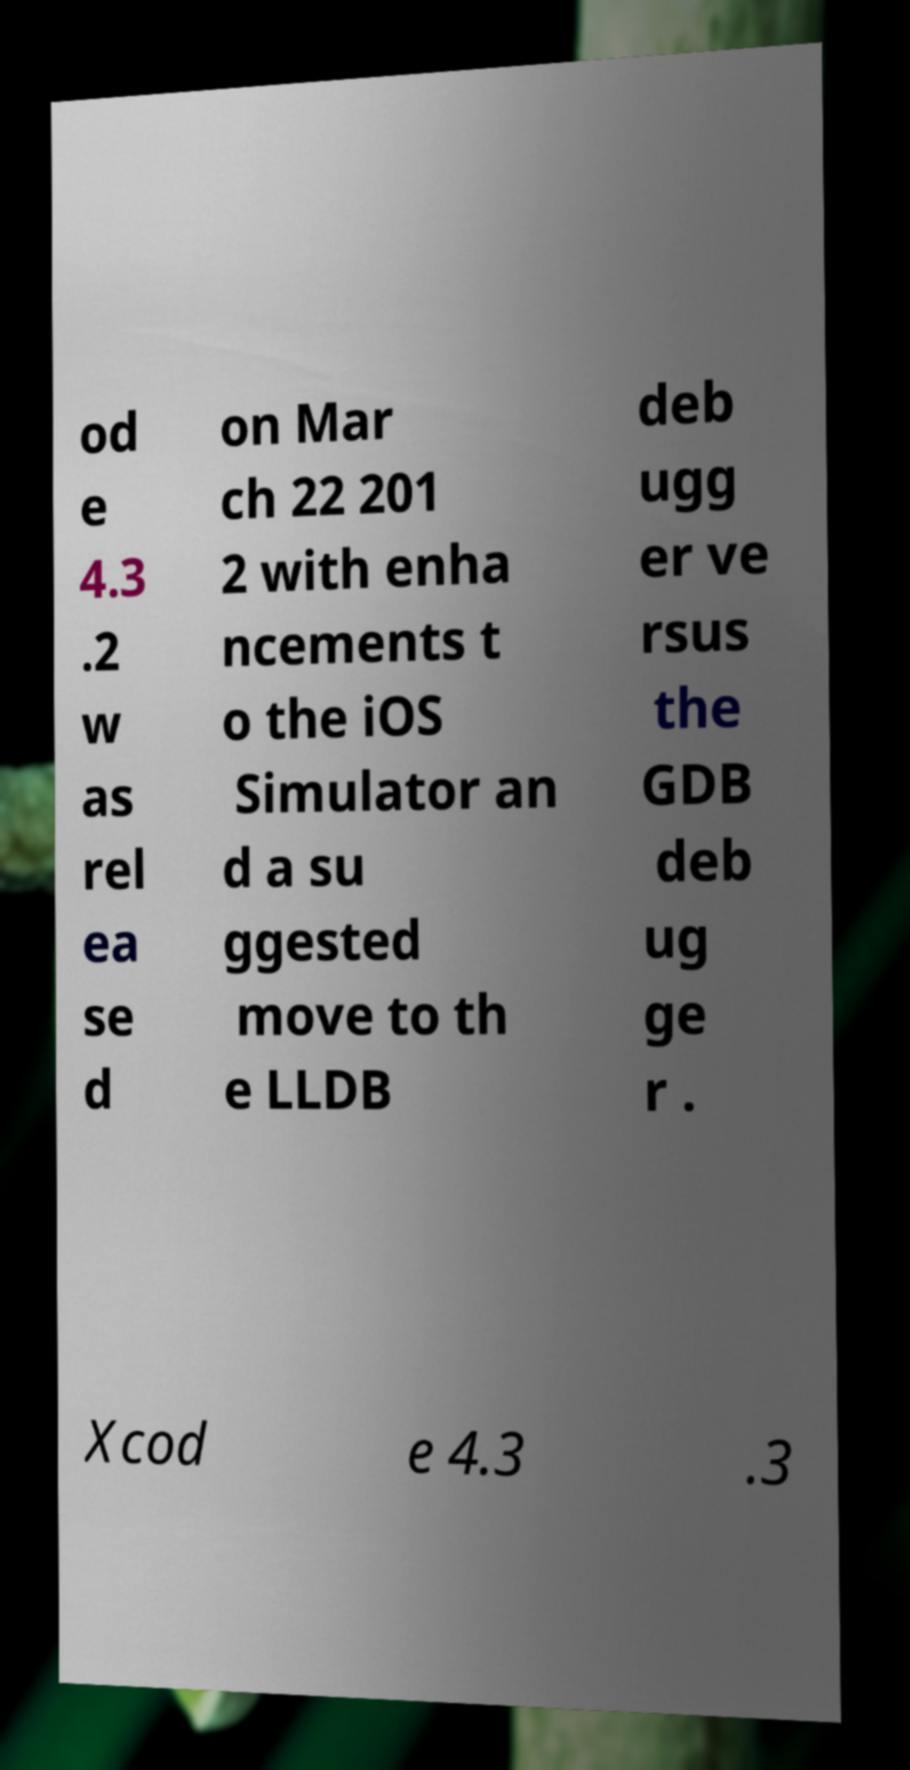Can you read and provide the text displayed in the image?This photo seems to have some interesting text. Can you extract and type it out for me? od e 4.3 .2 w as rel ea se d on Mar ch 22 201 2 with enha ncements t o the iOS Simulator an d a su ggested move to th e LLDB deb ugg er ve rsus the GDB deb ug ge r . Xcod e 4.3 .3 